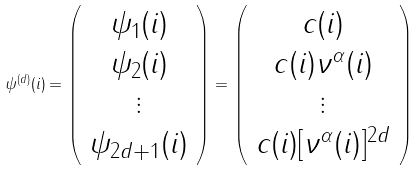<formula> <loc_0><loc_0><loc_500><loc_500>\psi ^ { ( d ) } ( i ) = \left ( \begin{array} { c } { { { \psi _ { 1 } ( i ) } } } \\ { { { \psi _ { 2 } ( i ) } } } \\ \vdots \\ { { { \psi _ { 2 d + 1 } ( i ) } } } \end{array} \right ) = \left ( \begin{array} { c } { c ( i ) } \\ { { { c ( i ) \nu ^ { \alpha } ( i ) } } } \\ \vdots \\ { { { c ( i ) [ \nu ^ { \alpha } ( i ) ] ^ { 2 d } } } } \end{array} \right )</formula> 